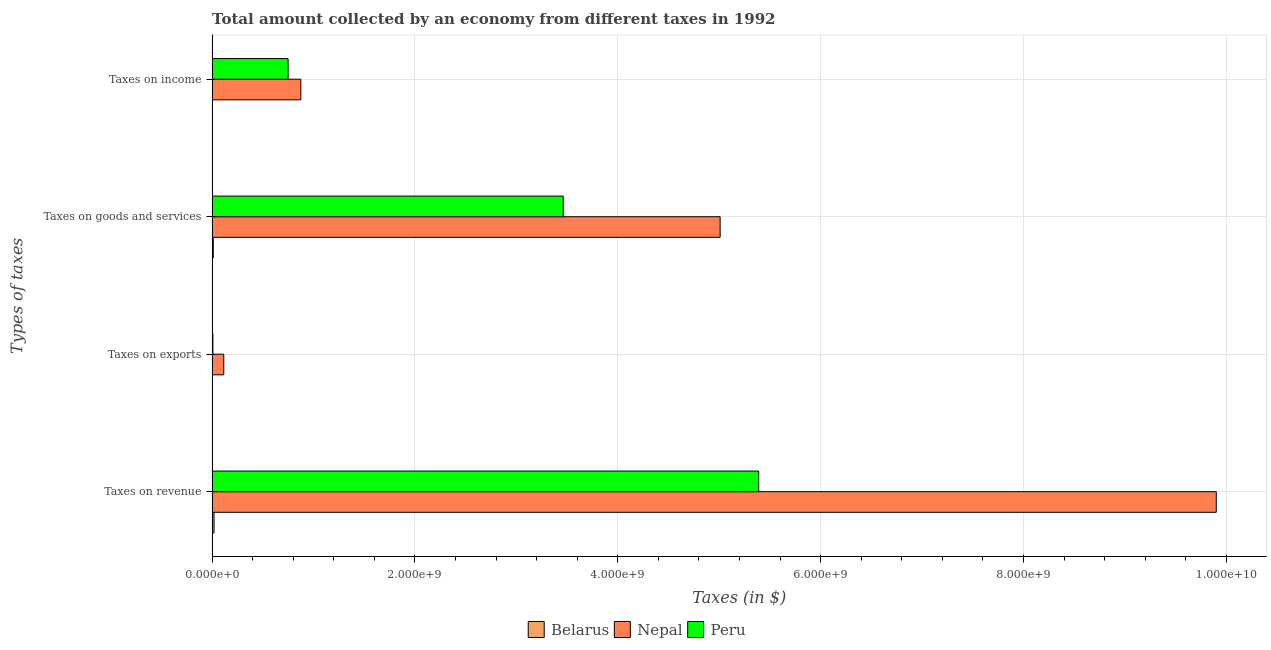Are the number of bars per tick equal to the number of legend labels?
Ensure brevity in your answer.  Yes. Are the number of bars on each tick of the Y-axis equal?
Make the answer very short. Yes. How many bars are there on the 3rd tick from the top?
Give a very brief answer. 3. How many bars are there on the 3rd tick from the bottom?
Provide a succinct answer. 3. What is the label of the 2nd group of bars from the top?
Keep it short and to the point. Taxes on goods and services. What is the amount collected as tax on exports in Belarus?
Your answer should be very brief. 1.00e+06. Across all countries, what is the maximum amount collected as tax on goods?
Provide a short and direct response. 5.01e+09. Across all countries, what is the minimum amount collected as tax on goods?
Your answer should be very brief. 1.15e+07. In which country was the amount collected as tax on income maximum?
Make the answer very short. Nepal. In which country was the amount collected as tax on income minimum?
Your answer should be very brief. Belarus. What is the total amount collected as tax on goods in the graph?
Offer a very short reply. 8.48e+09. What is the difference between the amount collected as tax on goods in Nepal and that in Peru?
Your response must be concise. 1.55e+09. What is the difference between the amount collected as tax on exports in Nepal and the amount collected as tax on income in Belarus?
Give a very brief answer. 1.12e+08. What is the average amount collected as tax on goods per country?
Offer a very short reply. 2.83e+09. What is the difference between the amount collected as tax on income and amount collected as tax on exports in Nepal?
Offer a terse response. 7.60e+08. What is the ratio of the amount collected as tax on exports in Peru to that in Belarus?
Make the answer very short. 7.48. Is the difference between the amount collected as tax on revenue in Belarus and Nepal greater than the difference between the amount collected as tax on goods in Belarus and Nepal?
Your answer should be compact. No. What is the difference between the highest and the second highest amount collected as tax on revenue?
Make the answer very short. 4.51e+09. What is the difference between the highest and the lowest amount collected as tax on income?
Make the answer very short. 8.72e+08. Is the sum of the amount collected as tax on revenue in Nepal and Peru greater than the maximum amount collected as tax on goods across all countries?
Provide a succinct answer. Yes. Is it the case that in every country, the sum of the amount collected as tax on exports and amount collected as tax on goods is greater than the sum of amount collected as tax on income and amount collected as tax on revenue?
Give a very brief answer. No. What does the 3rd bar from the top in Taxes on exports represents?
Your answer should be very brief. Belarus. How many bars are there?
Your response must be concise. 12. Are all the bars in the graph horizontal?
Ensure brevity in your answer.  Yes. How many countries are there in the graph?
Your response must be concise. 3. Does the graph contain grids?
Your answer should be compact. Yes. How many legend labels are there?
Provide a short and direct response. 3. What is the title of the graph?
Provide a succinct answer. Total amount collected by an economy from different taxes in 1992. Does "Yemen, Rep." appear as one of the legend labels in the graph?
Provide a short and direct response. No. What is the label or title of the X-axis?
Offer a terse response. Taxes (in $). What is the label or title of the Y-axis?
Your answer should be compact. Types of taxes. What is the Taxes (in $) in Belarus in Taxes on revenue?
Provide a succinct answer. 1.89e+07. What is the Taxes (in $) of Nepal in Taxes on revenue?
Offer a terse response. 9.90e+09. What is the Taxes (in $) of Peru in Taxes on revenue?
Ensure brevity in your answer.  5.39e+09. What is the Taxes (in $) in Belarus in Taxes on exports?
Your answer should be very brief. 1.00e+06. What is the Taxes (in $) in Nepal in Taxes on exports?
Offer a very short reply. 1.15e+08. What is the Taxes (in $) of Peru in Taxes on exports?
Ensure brevity in your answer.  7.48e+06. What is the Taxes (in $) in Belarus in Taxes on goods and services?
Keep it short and to the point. 1.15e+07. What is the Taxes (in $) in Nepal in Taxes on goods and services?
Offer a terse response. 5.01e+09. What is the Taxes (in $) of Peru in Taxes on goods and services?
Keep it short and to the point. 3.46e+09. What is the Taxes (in $) in Belarus in Taxes on income?
Offer a very short reply. 3.40e+06. What is the Taxes (in $) of Nepal in Taxes on income?
Your answer should be compact. 8.75e+08. What is the Taxes (in $) of Peru in Taxes on income?
Provide a succinct answer. 7.49e+08. Across all Types of taxes, what is the maximum Taxes (in $) of Belarus?
Offer a very short reply. 1.89e+07. Across all Types of taxes, what is the maximum Taxes (in $) of Nepal?
Provide a succinct answer. 9.90e+09. Across all Types of taxes, what is the maximum Taxes (in $) of Peru?
Give a very brief answer. 5.39e+09. Across all Types of taxes, what is the minimum Taxes (in $) in Belarus?
Your response must be concise. 1.00e+06. Across all Types of taxes, what is the minimum Taxes (in $) of Nepal?
Provide a succinct answer. 1.15e+08. Across all Types of taxes, what is the minimum Taxes (in $) in Peru?
Offer a very short reply. 7.48e+06. What is the total Taxes (in $) in Belarus in the graph?
Make the answer very short. 3.48e+07. What is the total Taxes (in $) in Nepal in the graph?
Your response must be concise. 1.59e+1. What is the total Taxes (in $) in Peru in the graph?
Give a very brief answer. 9.61e+09. What is the difference between the Taxes (in $) in Belarus in Taxes on revenue and that in Taxes on exports?
Your answer should be very brief. 1.79e+07. What is the difference between the Taxes (in $) of Nepal in Taxes on revenue and that in Taxes on exports?
Your answer should be compact. 9.79e+09. What is the difference between the Taxes (in $) of Peru in Taxes on revenue and that in Taxes on exports?
Your answer should be compact. 5.38e+09. What is the difference between the Taxes (in $) of Belarus in Taxes on revenue and that in Taxes on goods and services?
Provide a succinct answer. 7.40e+06. What is the difference between the Taxes (in $) in Nepal in Taxes on revenue and that in Taxes on goods and services?
Your answer should be compact. 4.89e+09. What is the difference between the Taxes (in $) in Peru in Taxes on revenue and that in Taxes on goods and services?
Provide a short and direct response. 1.93e+09. What is the difference between the Taxes (in $) in Belarus in Taxes on revenue and that in Taxes on income?
Your answer should be very brief. 1.55e+07. What is the difference between the Taxes (in $) in Nepal in Taxes on revenue and that in Taxes on income?
Ensure brevity in your answer.  9.03e+09. What is the difference between the Taxes (in $) of Peru in Taxes on revenue and that in Taxes on income?
Your answer should be very brief. 4.64e+09. What is the difference between the Taxes (in $) in Belarus in Taxes on exports and that in Taxes on goods and services?
Offer a very short reply. -1.05e+07. What is the difference between the Taxes (in $) in Nepal in Taxes on exports and that in Taxes on goods and services?
Your response must be concise. -4.89e+09. What is the difference between the Taxes (in $) in Peru in Taxes on exports and that in Taxes on goods and services?
Offer a terse response. -3.45e+09. What is the difference between the Taxes (in $) in Belarus in Taxes on exports and that in Taxes on income?
Keep it short and to the point. -2.40e+06. What is the difference between the Taxes (in $) in Nepal in Taxes on exports and that in Taxes on income?
Your answer should be compact. -7.60e+08. What is the difference between the Taxes (in $) in Peru in Taxes on exports and that in Taxes on income?
Give a very brief answer. -7.42e+08. What is the difference between the Taxes (in $) in Belarus in Taxes on goods and services and that in Taxes on income?
Provide a succinct answer. 8.10e+06. What is the difference between the Taxes (in $) in Nepal in Taxes on goods and services and that in Taxes on income?
Keep it short and to the point. 4.13e+09. What is the difference between the Taxes (in $) of Peru in Taxes on goods and services and that in Taxes on income?
Provide a short and direct response. 2.71e+09. What is the difference between the Taxes (in $) in Belarus in Taxes on revenue and the Taxes (in $) in Nepal in Taxes on exports?
Provide a succinct answer. -9.61e+07. What is the difference between the Taxes (in $) in Belarus in Taxes on revenue and the Taxes (in $) in Peru in Taxes on exports?
Provide a short and direct response. 1.14e+07. What is the difference between the Taxes (in $) of Nepal in Taxes on revenue and the Taxes (in $) of Peru in Taxes on exports?
Give a very brief answer. 9.89e+09. What is the difference between the Taxes (in $) in Belarus in Taxes on revenue and the Taxes (in $) in Nepal in Taxes on goods and services?
Your answer should be compact. -4.99e+09. What is the difference between the Taxes (in $) of Belarus in Taxes on revenue and the Taxes (in $) of Peru in Taxes on goods and services?
Your response must be concise. -3.44e+09. What is the difference between the Taxes (in $) of Nepal in Taxes on revenue and the Taxes (in $) of Peru in Taxes on goods and services?
Ensure brevity in your answer.  6.44e+09. What is the difference between the Taxes (in $) of Belarus in Taxes on revenue and the Taxes (in $) of Nepal in Taxes on income?
Give a very brief answer. -8.56e+08. What is the difference between the Taxes (in $) in Belarus in Taxes on revenue and the Taxes (in $) in Peru in Taxes on income?
Your answer should be compact. -7.30e+08. What is the difference between the Taxes (in $) of Nepal in Taxes on revenue and the Taxes (in $) of Peru in Taxes on income?
Your response must be concise. 9.15e+09. What is the difference between the Taxes (in $) in Belarus in Taxes on exports and the Taxes (in $) in Nepal in Taxes on goods and services?
Offer a terse response. -5.01e+09. What is the difference between the Taxes (in $) in Belarus in Taxes on exports and the Taxes (in $) in Peru in Taxes on goods and services?
Offer a very short reply. -3.46e+09. What is the difference between the Taxes (in $) of Nepal in Taxes on exports and the Taxes (in $) of Peru in Taxes on goods and services?
Your response must be concise. -3.35e+09. What is the difference between the Taxes (in $) in Belarus in Taxes on exports and the Taxes (in $) in Nepal in Taxes on income?
Provide a short and direct response. -8.74e+08. What is the difference between the Taxes (in $) of Belarus in Taxes on exports and the Taxes (in $) of Peru in Taxes on income?
Provide a short and direct response. -7.48e+08. What is the difference between the Taxes (in $) in Nepal in Taxes on exports and the Taxes (in $) in Peru in Taxes on income?
Give a very brief answer. -6.34e+08. What is the difference between the Taxes (in $) of Belarus in Taxes on goods and services and the Taxes (in $) of Nepal in Taxes on income?
Make the answer very short. -8.64e+08. What is the difference between the Taxes (in $) of Belarus in Taxes on goods and services and the Taxes (in $) of Peru in Taxes on income?
Ensure brevity in your answer.  -7.38e+08. What is the difference between the Taxes (in $) in Nepal in Taxes on goods and services and the Taxes (in $) in Peru in Taxes on income?
Make the answer very short. 4.26e+09. What is the average Taxes (in $) of Belarus per Types of taxes?
Offer a terse response. 8.70e+06. What is the average Taxes (in $) in Nepal per Types of taxes?
Your answer should be very brief. 3.98e+09. What is the average Taxes (in $) in Peru per Types of taxes?
Make the answer very short. 2.40e+09. What is the difference between the Taxes (in $) of Belarus and Taxes (in $) of Nepal in Taxes on revenue?
Provide a short and direct response. -9.88e+09. What is the difference between the Taxes (in $) in Belarus and Taxes (in $) in Peru in Taxes on revenue?
Keep it short and to the point. -5.37e+09. What is the difference between the Taxes (in $) in Nepal and Taxes (in $) in Peru in Taxes on revenue?
Your answer should be compact. 4.51e+09. What is the difference between the Taxes (in $) of Belarus and Taxes (in $) of Nepal in Taxes on exports?
Your response must be concise. -1.14e+08. What is the difference between the Taxes (in $) in Belarus and Taxes (in $) in Peru in Taxes on exports?
Give a very brief answer. -6.48e+06. What is the difference between the Taxes (in $) in Nepal and Taxes (in $) in Peru in Taxes on exports?
Your answer should be very brief. 1.08e+08. What is the difference between the Taxes (in $) of Belarus and Taxes (in $) of Nepal in Taxes on goods and services?
Ensure brevity in your answer.  -5.00e+09. What is the difference between the Taxes (in $) of Belarus and Taxes (in $) of Peru in Taxes on goods and services?
Your response must be concise. -3.45e+09. What is the difference between the Taxes (in $) in Nepal and Taxes (in $) in Peru in Taxes on goods and services?
Provide a succinct answer. 1.55e+09. What is the difference between the Taxes (in $) of Belarus and Taxes (in $) of Nepal in Taxes on income?
Your answer should be very brief. -8.72e+08. What is the difference between the Taxes (in $) in Belarus and Taxes (in $) in Peru in Taxes on income?
Provide a succinct answer. -7.46e+08. What is the difference between the Taxes (in $) in Nepal and Taxes (in $) in Peru in Taxes on income?
Your answer should be compact. 1.26e+08. What is the ratio of the Taxes (in $) in Belarus in Taxes on revenue to that in Taxes on exports?
Ensure brevity in your answer.  18.9. What is the ratio of the Taxes (in $) in Nepal in Taxes on revenue to that in Taxes on exports?
Keep it short and to the point. 86.1. What is the ratio of the Taxes (in $) in Peru in Taxes on revenue to that in Taxes on exports?
Give a very brief answer. 720.46. What is the ratio of the Taxes (in $) in Belarus in Taxes on revenue to that in Taxes on goods and services?
Offer a very short reply. 1.64. What is the ratio of the Taxes (in $) of Nepal in Taxes on revenue to that in Taxes on goods and services?
Give a very brief answer. 1.98. What is the ratio of the Taxes (in $) of Peru in Taxes on revenue to that in Taxes on goods and services?
Your answer should be very brief. 1.56. What is the ratio of the Taxes (in $) in Belarus in Taxes on revenue to that in Taxes on income?
Give a very brief answer. 5.56. What is the ratio of the Taxes (in $) of Nepal in Taxes on revenue to that in Taxes on income?
Your response must be concise. 11.32. What is the ratio of the Taxes (in $) in Peru in Taxes on revenue to that in Taxes on income?
Offer a terse response. 7.19. What is the ratio of the Taxes (in $) of Belarus in Taxes on exports to that in Taxes on goods and services?
Give a very brief answer. 0.09. What is the ratio of the Taxes (in $) of Nepal in Taxes on exports to that in Taxes on goods and services?
Your answer should be compact. 0.02. What is the ratio of the Taxes (in $) in Peru in Taxes on exports to that in Taxes on goods and services?
Make the answer very short. 0. What is the ratio of the Taxes (in $) in Belarus in Taxes on exports to that in Taxes on income?
Make the answer very short. 0.29. What is the ratio of the Taxes (in $) in Nepal in Taxes on exports to that in Taxes on income?
Your response must be concise. 0.13. What is the ratio of the Taxes (in $) of Belarus in Taxes on goods and services to that in Taxes on income?
Your response must be concise. 3.38. What is the ratio of the Taxes (in $) of Nepal in Taxes on goods and services to that in Taxes on income?
Your response must be concise. 5.72. What is the ratio of the Taxes (in $) in Peru in Taxes on goods and services to that in Taxes on income?
Your response must be concise. 4.62. What is the difference between the highest and the second highest Taxes (in $) of Belarus?
Offer a very short reply. 7.40e+06. What is the difference between the highest and the second highest Taxes (in $) of Nepal?
Keep it short and to the point. 4.89e+09. What is the difference between the highest and the second highest Taxes (in $) of Peru?
Your answer should be very brief. 1.93e+09. What is the difference between the highest and the lowest Taxes (in $) of Belarus?
Your answer should be compact. 1.79e+07. What is the difference between the highest and the lowest Taxes (in $) of Nepal?
Your answer should be very brief. 9.79e+09. What is the difference between the highest and the lowest Taxes (in $) of Peru?
Your answer should be compact. 5.38e+09. 